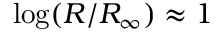Convert formula to latex. <formula><loc_0><loc_0><loc_500><loc_500>\log ( R / R _ { \infty } ) \approx 1</formula> 